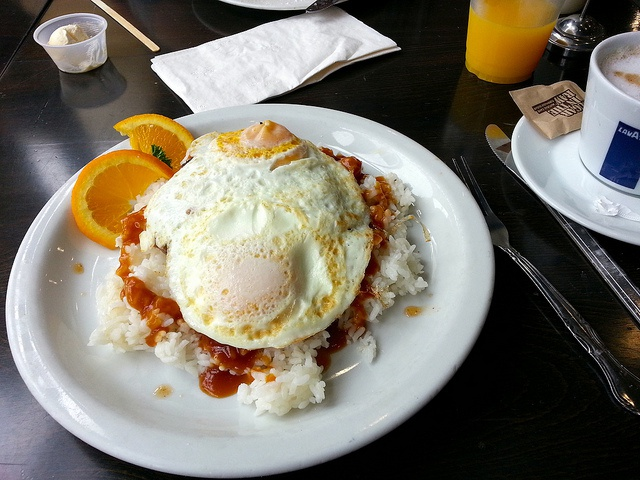Describe the objects in this image and their specific colors. I can see dining table in black, lightgray, darkgray, and gray tones, cup in black, lightgray, darkgray, and navy tones, cup in black, olive, orange, and maroon tones, orange in black, orange, red, and tan tones, and fork in black, gray, darkgray, and lightgray tones in this image. 